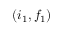Convert formula to latex. <formula><loc_0><loc_0><loc_500><loc_500>( i _ { 1 } , f _ { 1 } )</formula> 